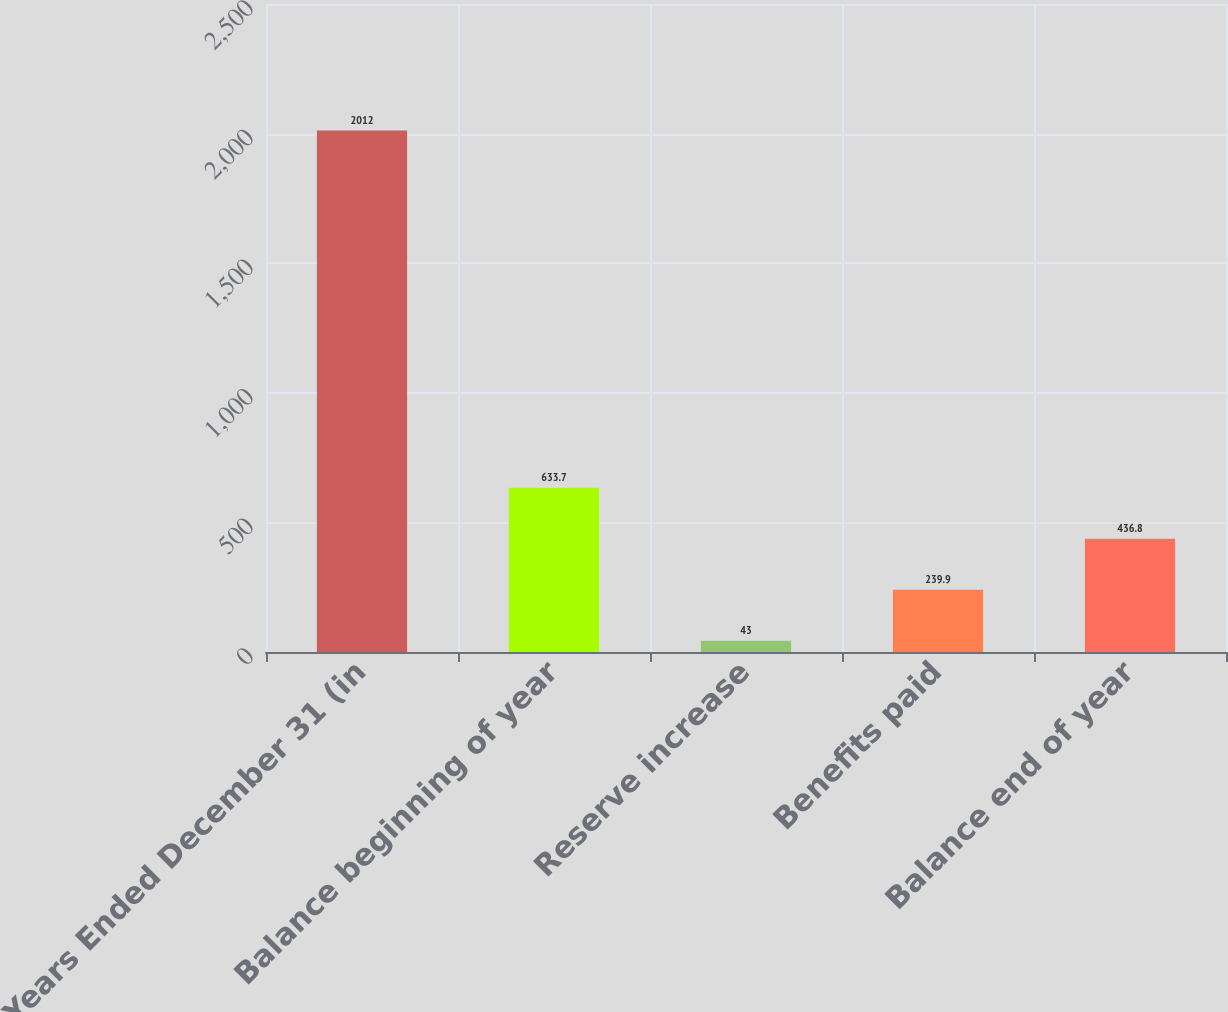<chart> <loc_0><loc_0><loc_500><loc_500><bar_chart><fcel>Years Ended December 31 (in<fcel>Balance beginning of year<fcel>Reserve increase<fcel>Benefits paid<fcel>Balance end of year<nl><fcel>2012<fcel>633.7<fcel>43<fcel>239.9<fcel>436.8<nl></chart> 